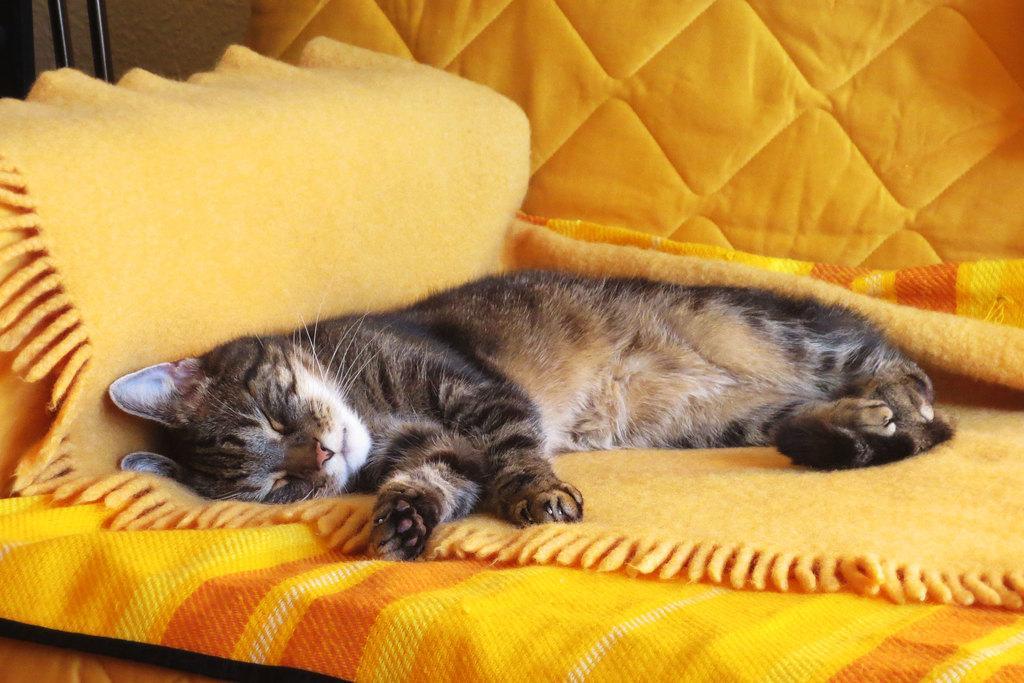Describe this image in one or two sentences. A cat is sleeping on a yellow surface. The background is yellow. 